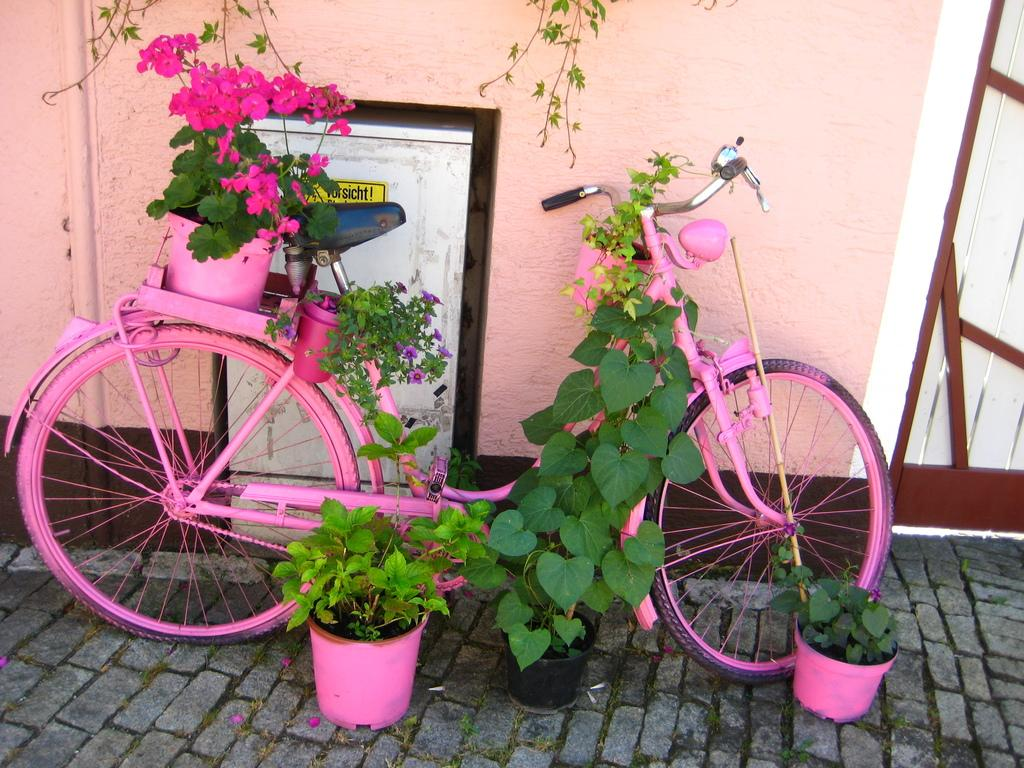What color is the bicycle in the image? The bicycle in the image is pink. Where is the bicycle located in relation to other objects? The bicycle is placed near a wall. What type of vegetation can be seen in the image? There are plants and flowers in the image. What objects are used to hold the plants and flowers? There are pots in the image. What architectural features can be seen in the background of the image? There is a wall, a door, and a sticker in the background of the image. Can you hear the jellyfish crying in the image? There are no jellyfish or sounds in the image, so it is not possible to hear any crying. 